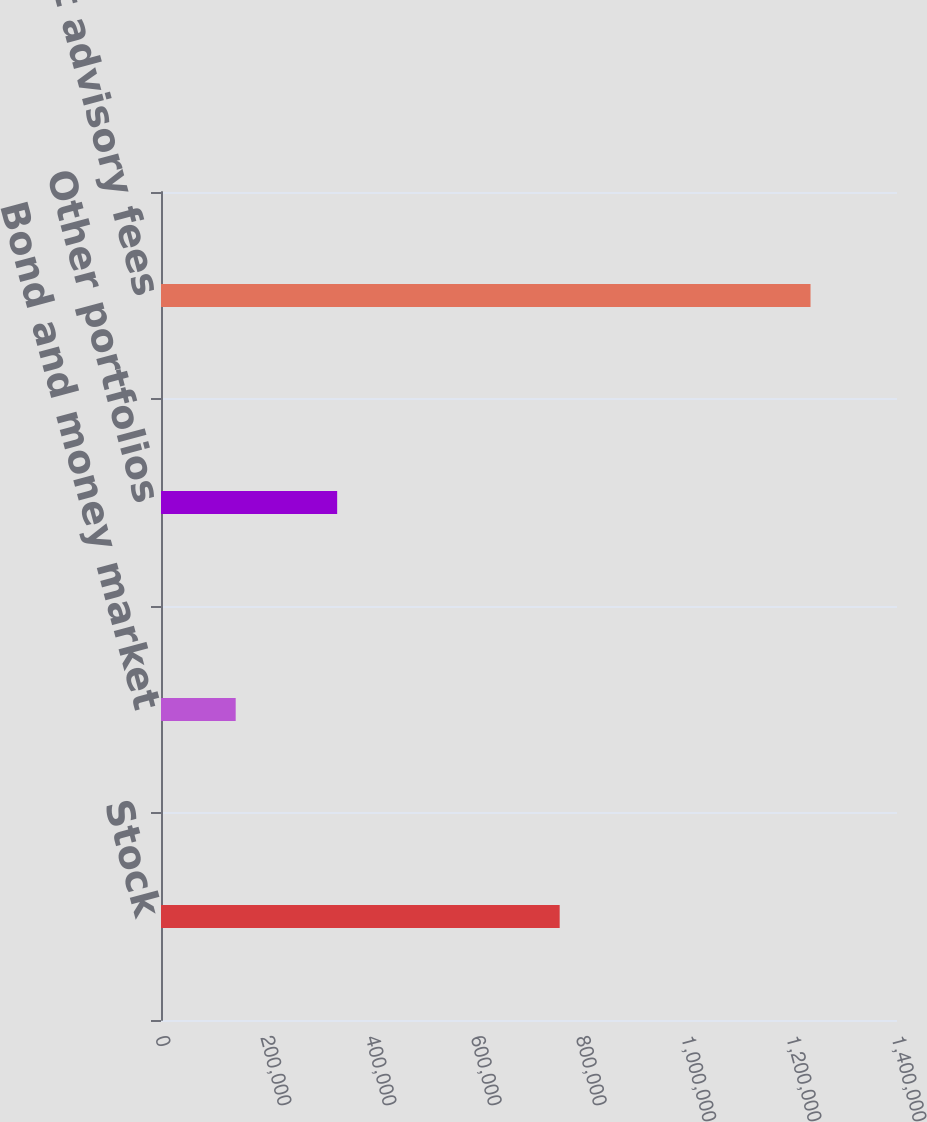<chart> <loc_0><loc_0><loc_500><loc_500><bar_chart><fcel>Stock<fcel>Bond and money market<fcel>Other portfolios<fcel>Total investment advisory fees<nl><fcel>758346<fcel>142057<fcel>335096<fcel>1.2355e+06<nl></chart> 